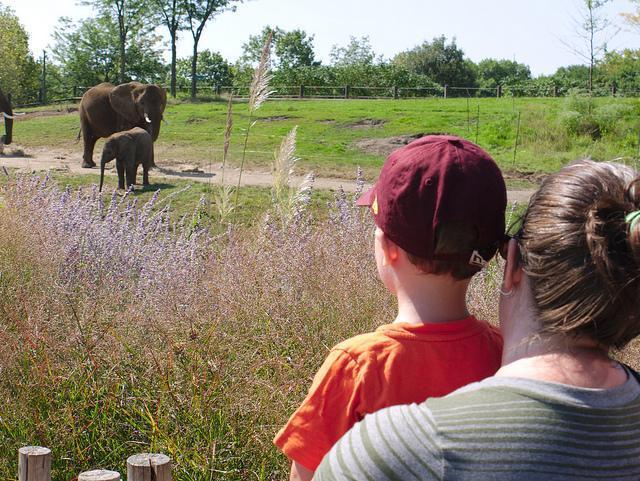How many elephants are in the field?
Give a very brief answer. 2. How many people in ponchos?
Give a very brief answer. 0. How many elephants are there?
Give a very brief answer. 2. How many people are there?
Give a very brief answer. 2. 